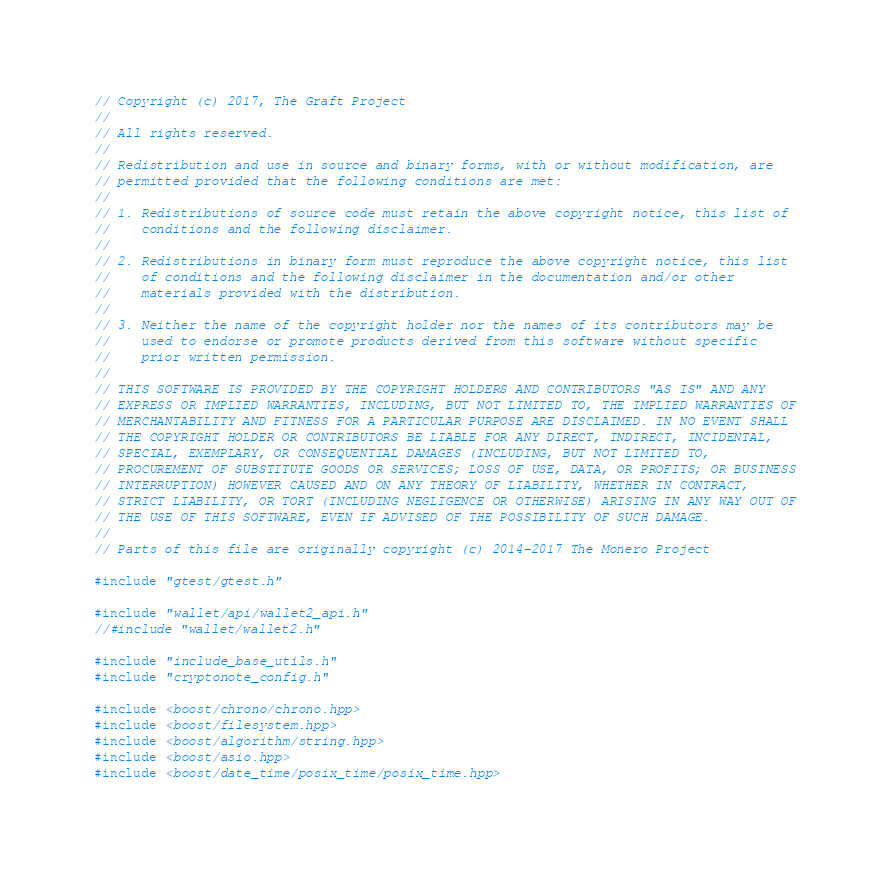Convert code to text. <code><loc_0><loc_0><loc_500><loc_500><_C++_>// Copyright (c) 2017, The Graft Project
//
// All rights reserved.
//
// Redistribution and use in source and binary forms, with or without modification, are
// permitted provided that the following conditions are met:
//
// 1. Redistributions of source code must retain the above copyright notice, this list of
//    conditions and the following disclaimer.
//
// 2. Redistributions in binary form must reproduce the above copyright notice, this list
//    of conditions and the following disclaimer in the documentation and/or other
//    materials provided with the distribution.
//
// 3. Neither the name of the copyright holder nor the names of its contributors may be
//    used to endorse or promote products derived from this software without specific
//    prior written permission.
//
// THIS SOFTWARE IS PROVIDED BY THE COPYRIGHT HOLDERS AND CONTRIBUTORS "AS IS" AND ANY
// EXPRESS OR IMPLIED WARRANTIES, INCLUDING, BUT NOT LIMITED TO, THE IMPLIED WARRANTIES OF
// MERCHANTABILITY AND FITNESS FOR A PARTICULAR PURPOSE ARE DISCLAIMED. IN NO EVENT SHALL
// THE COPYRIGHT HOLDER OR CONTRIBUTORS BE LIABLE FOR ANY DIRECT, INDIRECT, INCIDENTAL,
// SPECIAL, EXEMPLARY, OR CONSEQUENTIAL DAMAGES (INCLUDING, BUT NOT LIMITED TO,
// PROCUREMENT OF SUBSTITUTE GOODS OR SERVICES; LOSS OF USE, DATA, OR PROFITS; OR BUSINESS
// INTERRUPTION) HOWEVER CAUSED AND ON ANY THEORY OF LIABILITY, WHETHER IN CONTRACT,
// STRICT LIABILITY, OR TORT (INCLUDING NEGLIGENCE OR OTHERWISE) ARISING IN ANY WAY OUT OF
// THE USE OF THIS SOFTWARE, EVEN IF ADVISED OF THE POSSIBILITY OF SUCH DAMAGE.
//
// Parts of this file are originally copyright (c) 2014-2017 The Monero Project

#include "gtest/gtest.h"

#include "wallet/api/wallet2_api.h"
//#include "wallet/wallet2.h"

#include "include_base_utils.h"
#include "cryptonote_config.h"

#include <boost/chrono/chrono.hpp>
#include <boost/filesystem.hpp>
#include <boost/algorithm/string.hpp>
#include <boost/asio.hpp>
#include <boost/date_time/posix_time/posix_time.hpp></code> 